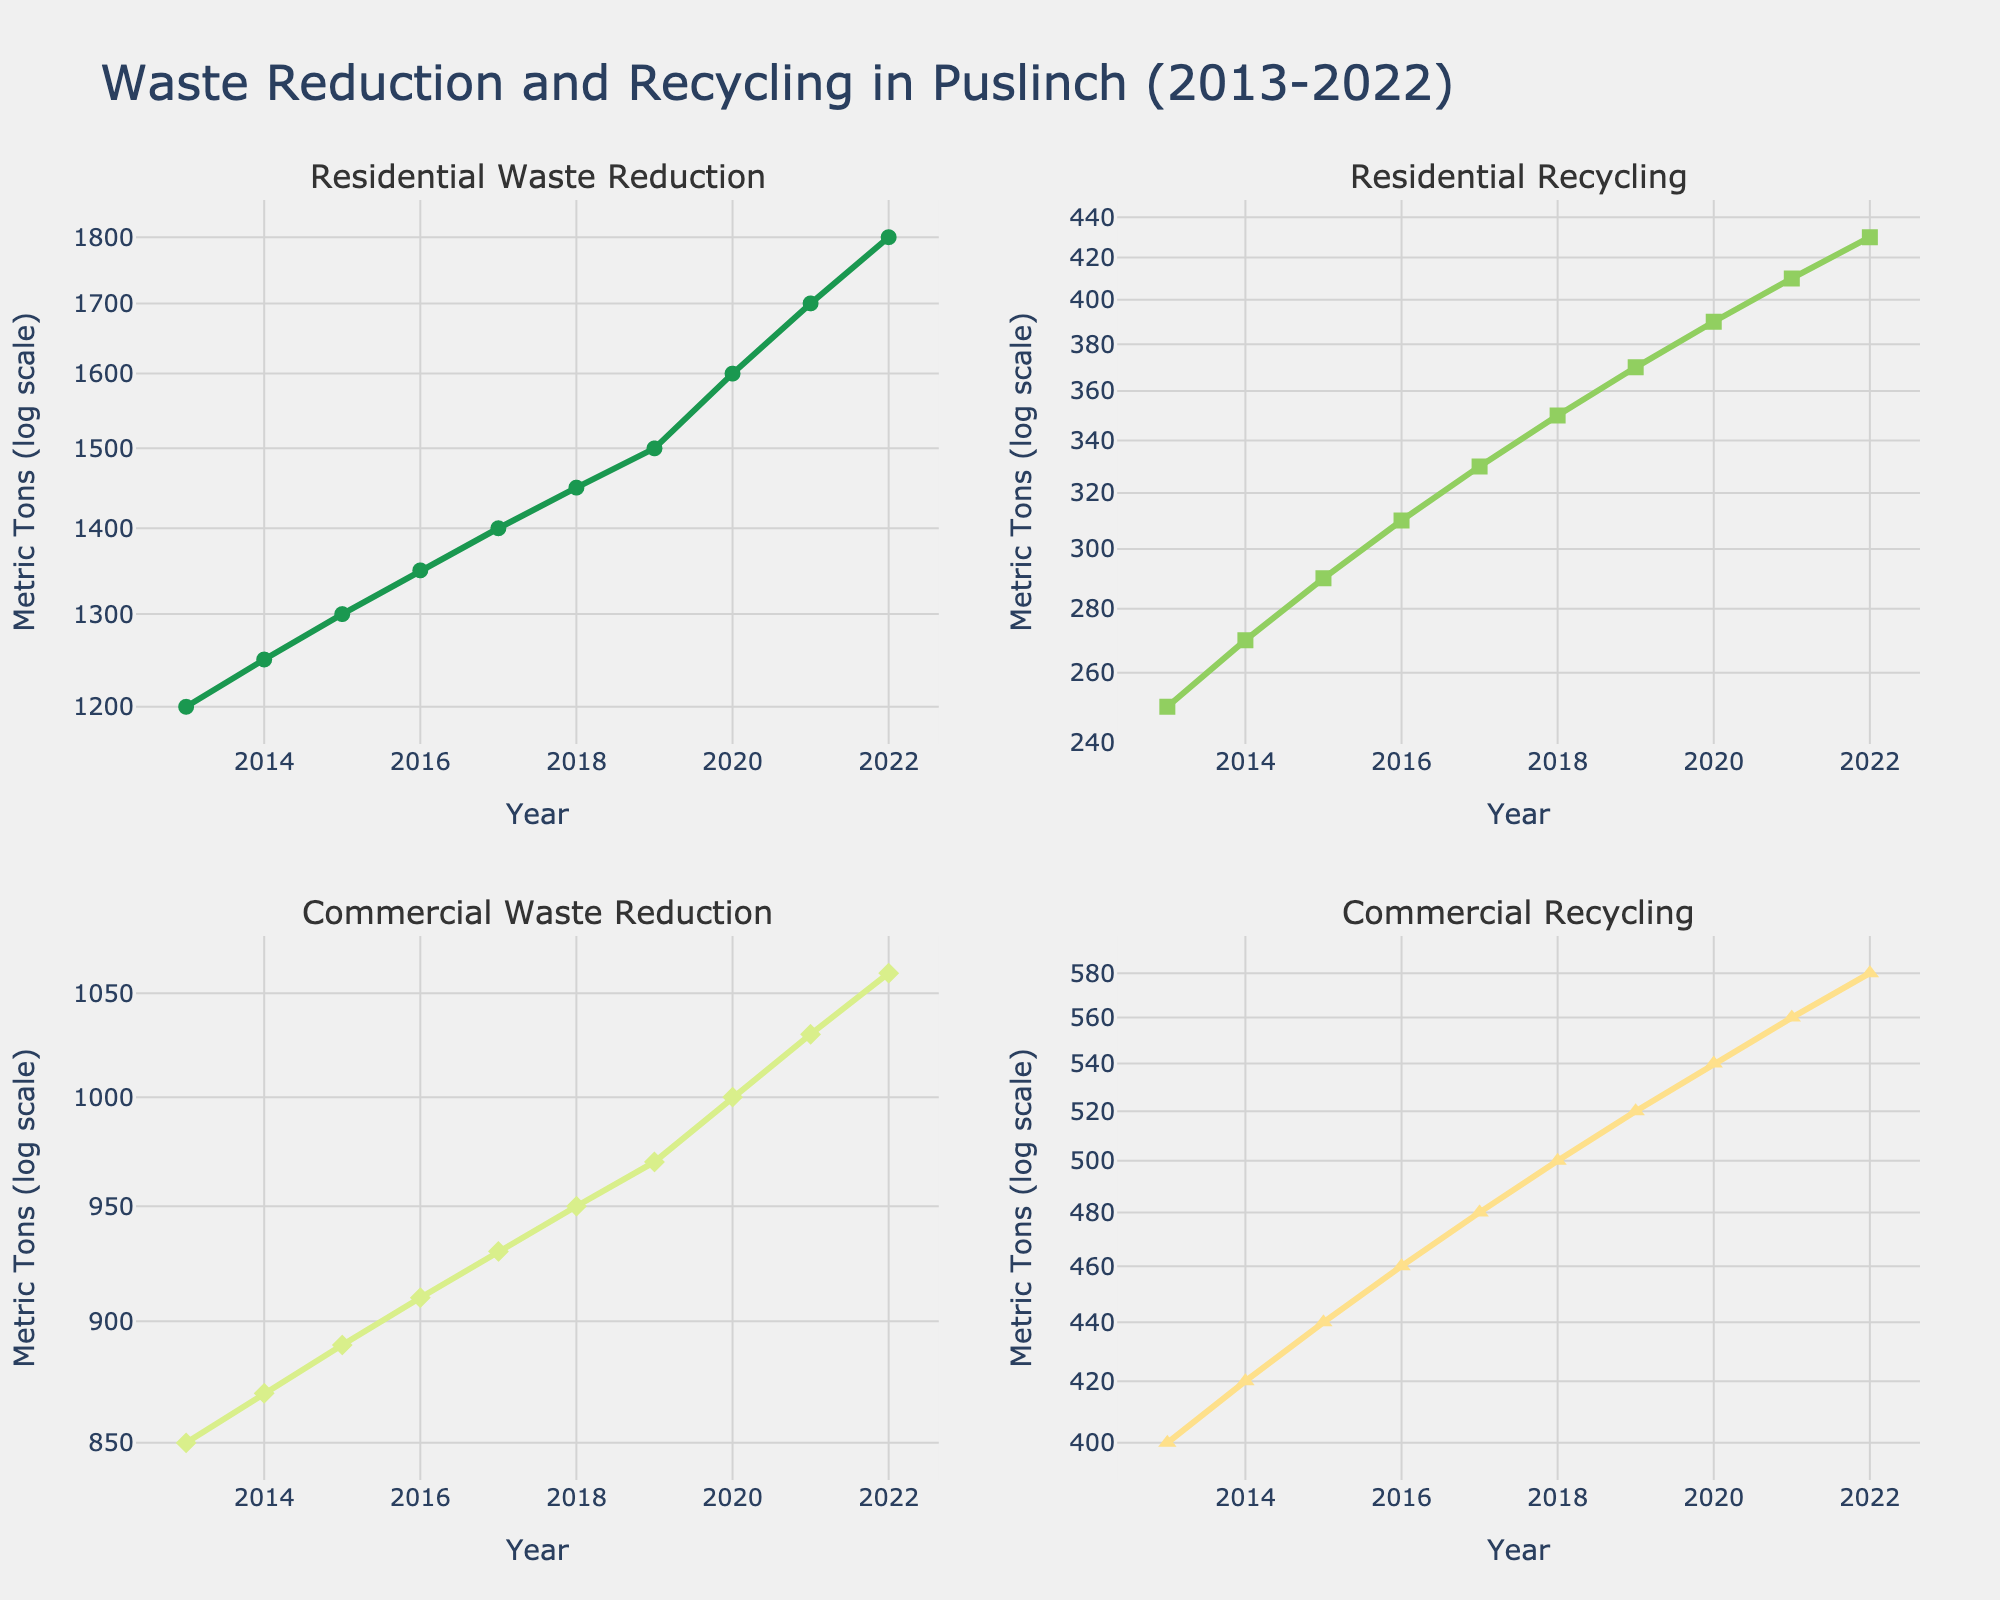What is the title of the figure? The title of the figure is displayed prominently at the top. It reads "Waste Reduction and Recycling in Puslinch (2013-2022)."
Answer: Waste Reduction and Recycling in Puslinch (2013-2022) What color is used for representing Residential Waste Reduction? In the Residential Waste Reduction subplot, the lines and markers are color coded. The green color is used, which is the first in the custom color palette.
Answer: Green How many years of data are shown in the figure? The x-axis of each subplot represents the years, starting from 2013 to 2022. Counting all the years inclusive, the number of years is 10.
Answer: 10 Which sector shows the highest recycling metric in 2022? By comparing the y-values for both Residential and Commercial Recycling subplots in 2022, Commercial Recycling has a higher value (580 metric tons) compared to Residential Recycling (430 metric tons).
Answer: Commercial What is the total Residential Waste Reduction from 2013 to 2022? Adding up the values of Residential Waste Reduction from 2013 to 2022: 1200 + 1250 + 1300 + 1350 + 1400 + 1450 + 1500 + 1600 + 1700 + 1800 = 14550 metric tons.
Answer: 14550 metric tons Which year saw the highest Commercial Waste Reduction? By reviewing the Commercial Waste Reduction subplot, the highest value on the y-axis occurs in 2022, with 1060 metric tons.
Answer: 2022 What is the difference in recycling metrics between Residential and Commercial sectors in 2018? From the subplots, in 2018, Residential Recycling is 350 metric tons, and Commercial Recycling is 500 metric tons. The difference is 500 - 350 = 150 metric tons.
Answer: 150 metric tons Did the residential recycling increase every year? Examining the subplot for Residential Recycling, the y-axis values consistently increase every year from 250 to 430 metric tons, showing a yearly increase.
Answer: Yes What is the average annual waste reduction for the commercial sector over the decade? Adding the Commercial Waste Reduction values from 2013 to 2022 results in 850 + 870 + 890 + 910 + 930 + 950 + 970 + 1000 + 1030 + 1060 = 9360 metric tons. Dividing by 10, the average annual waste reduction is 9360 / 10 = 936 metric tons.
Answer: 936 metric tons Which subplot shows the least growth in the dataset? Comparing the slopes in all subplots, the Commercial Waste Reduction subplot shows relatively slower growth over time compared to the others, starting from 850 metric tons in 2013 to 1060 metric tons in 2022.
Answer: Commercial Waste Reduction 